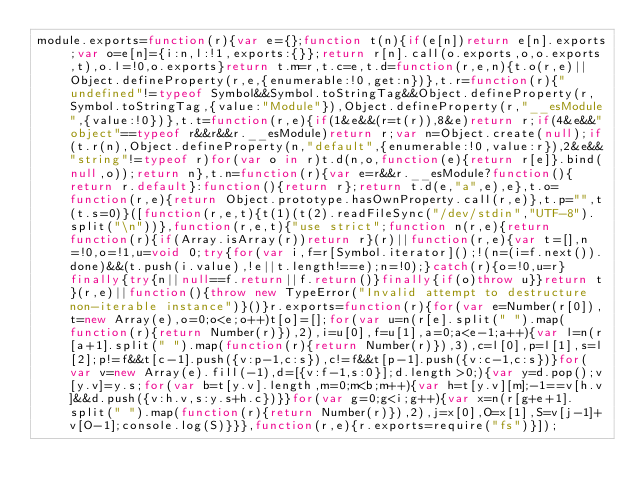<code> <loc_0><loc_0><loc_500><loc_500><_JavaScript_>module.exports=function(r){var e={};function t(n){if(e[n])return e[n].exports;var o=e[n]={i:n,l:!1,exports:{}};return r[n].call(o.exports,o,o.exports,t),o.l=!0,o.exports}return t.m=r,t.c=e,t.d=function(r,e,n){t.o(r,e)||Object.defineProperty(r,e,{enumerable:!0,get:n})},t.r=function(r){"undefined"!=typeof Symbol&&Symbol.toStringTag&&Object.defineProperty(r,Symbol.toStringTag,{value:"Module"}),Object.defineProperty(r,"__esModule",{value:!0})},t.t=function(r,e){if(1&e&&(r=t(r)),8&e)return r;if(4&e&&"object"==typeof r&&r&&r.__esModule)return r;var n=Object.create(null);if(t.r(n),Object.defineProperty(n,"default",{enumerable:!0,value:r}),2&e&&"string"!=typeof r)for(var o in r)t.d(n,o,function(e){return r[e]}.bind(null,o));return n},t.n=function(r){var e=r&&r.__esModule?function(){return r.default}:function(){return r};return t.d(e,"a",e),e},t.o=function(r,e){return Object.prototype.hasOwnProperty.call(r,e)},t.p="",t(t.s=0)}([function(r,e,t){t(1)(t(2).readFileSync("/dev/stdin","UTF-8").split("\n"))},function(r,e,t){"use strict";function n(r,e){return function(r){if(Array.isArray(r))return r}(r)||function(r,e){var t=[],n=!0,o=!1,u=void 0;try{for(var i,f=r[Symbol.iterator]();!(n=(i=f.next()).done)&&(t.push(i.value),!e||t.length!==e);n=!0);}catch(r){o=!0,u=r}finally{try{n||null==f.return||f.return()}finally{if(o)throw u}}return t}(r,e)||function(){throw new TypeError("Invalid attempt to destructure non-iterable instance")}()}r.exports=function(r){for(var e=Number(r[0]),t=new Array(e),o=0;o<e;o++)t[o]=[];for(var u=n(r[e].split(" ").map(function(r){return Number(r)}),2),i=u[0],f=u[1],a=0;a<e-1;a++){var l=n(r[a+1].split(" ").map(function(r){return Number(r)}),3),c=l[0],p=l[1],s=l[2];p!=f&&t[c-1].push({v:p-1,c:s}),c!=f&&t[p-1].push({v:c-1,c:s})}for(var v=new Array(e).fill(-1),d=[{v:f-1,s:0}];d.length>0;){var y=d.pop();v[y.v]=y.s;for(var b=t[y.v].length,m=0;m<b;m++){var h=t[y.v][m];-1==v[h.v]&&d.push({v:h.v,s:y.s+h.c})}}for(var g=0;g<i;g++){var x=n(r[g+e+1].split(" ").map(function(r){return Number(r)}),2),j=x[0],O=x[1],S=v[j-1]+v[O-1];console.log(S)}}},function(r,e){r.exports=require("fs")}]);</code> 